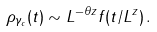Convert formula to latex. <formula><loc_0><loc_0><loc_500><loc_500>\rho _ { \gamma _ { c } } ( t ) \sim L ^ { - \theta z } f ( t / L ^ { z } ) \, .</formula> 